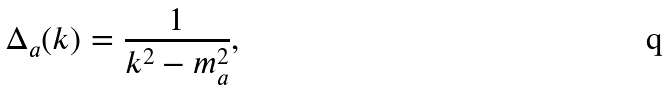<formula> <loc_0><loc_0><loc_500><loc_500>\Delta _ { a } ( k ) = \frac { 1 } { k ^ { 2 } - m _ { a } ^ { 2 } } ,</formula> 